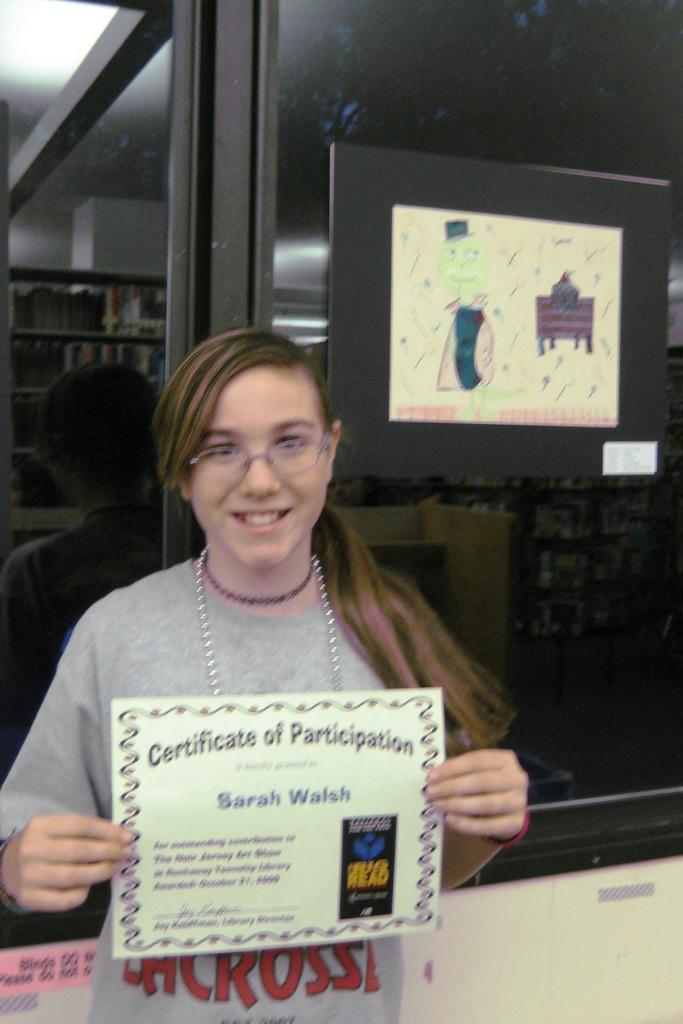Who is present in the image? There is a woman in the image. What is the woman doing in the image? The woman is smiling in the image. What is the woman holding in the image? The woman is holding a certificate in the image. What can be seen behind the woman in the image? There is a poster visible behind the woman on a glass surface. How many birds are flying in the image? There are no birds visible in the image. 